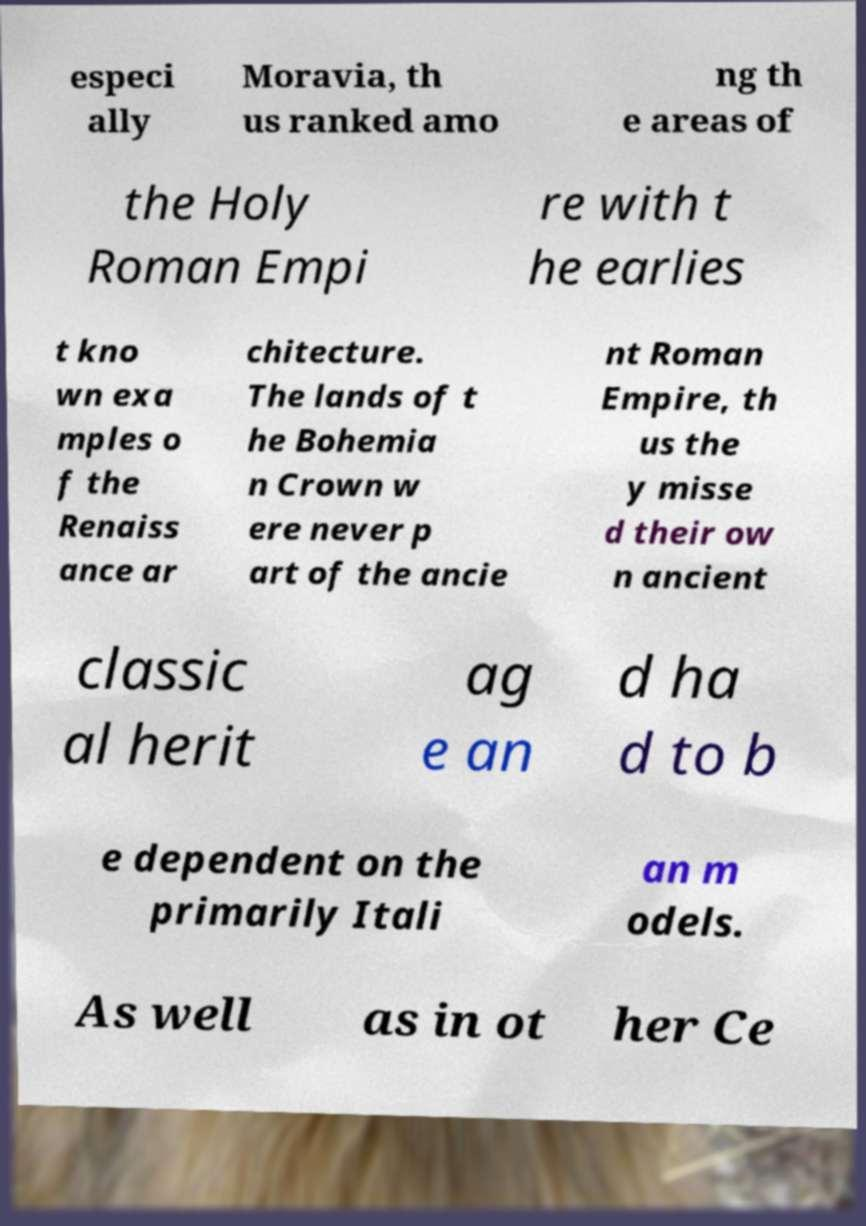Please identify and transcribe the text found in this image. especi ally Moravia, th us ranked amo ng th e areas of the Holy Roman Empi re with t he earlies t kno wn exa mples o f the Renaiss ance ar chitecture. The lands of t he Bohemia n Crown w ere never p art of the ancie nt Roman Empire, th us the y misse d their ow n ancient classic al herit ag e an d ha d to b e dependent on the primarily Itali an m odels. As well as in ot her Ce 